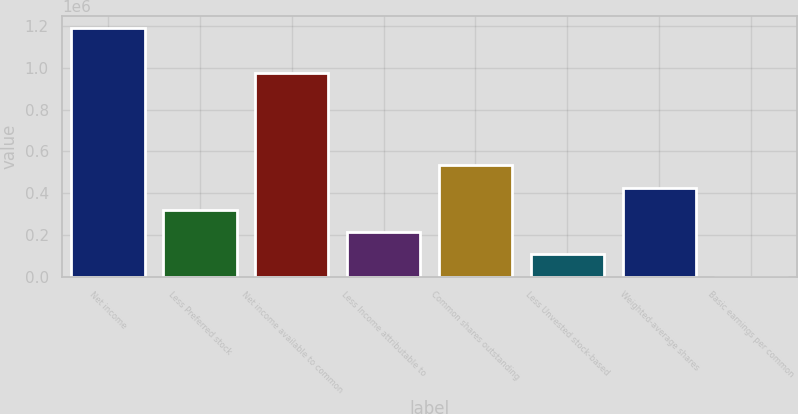<chart> <loc_0><loc_0><loc_500><loc_500><bar_chart><fcel>Net income<fcel>Less Preferred stock<fcel>Net income available to common<fcel>Less Income attributable to<fcel>Common shares outstanding<fcel>Less Unvested stock-based<fcel>Weighted-average shares<fcel>Basic earnings per common<nl><fcel>1.19178e+06<fcel>319879<fcel>978531<fcel>213255<fcel>533127<fcel>106631<fcel>426503<fcel>7.47<nl></chart> 